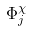Convert formula to latex. <formula><loc_0><loc_0><loc_500><loc_500>\Phi _ { j } ^ { \chi }</formula> 